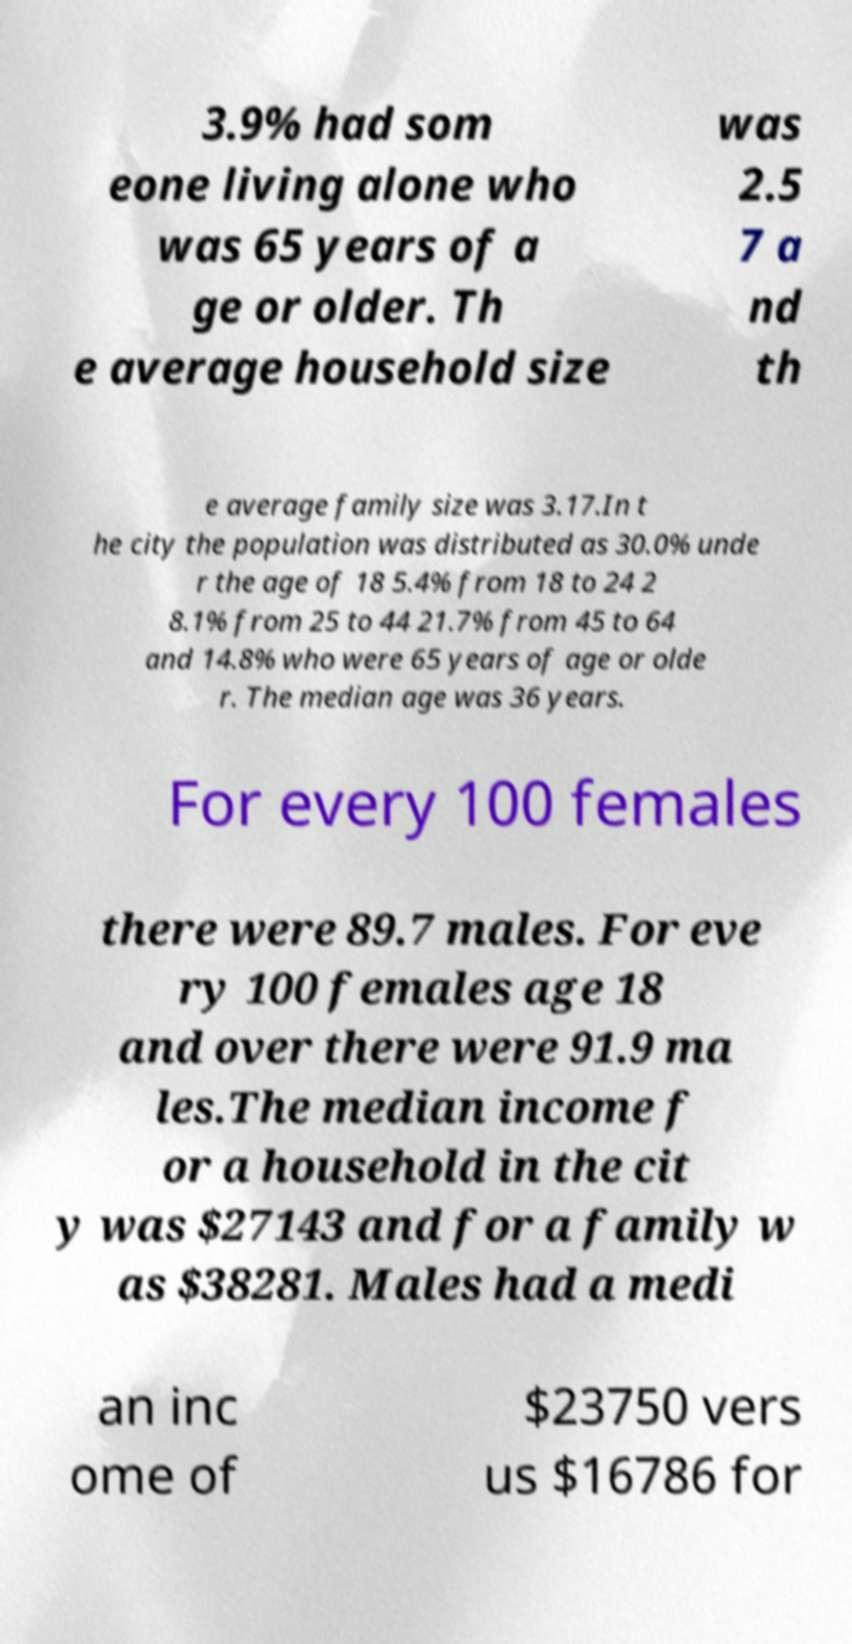What messages or text are displayed in this image? I need them in a readable, typed format. 3.9% had som eone living alone who was 65 years of a ge or older. Th e average household size was 2.5 7 a nd th e average family size was 3.17.In t he city the population was distributed as 30.0% unde r the age of 18 5.4% from 18 to 24 2 8.1% from 25 to 44 21.7% from 45 to 64 and 14.8% who were 65 years of age or olde r. The median age was 36 years. For every 100 females there were 89.7 males. For eve ry 100 females age 18 and over there were 91.9 ma les.The median income f or a household in the cit y was $27143 and for a family w as $38281. Males had a medi an inc ome of $23750 vers us $16786 for 